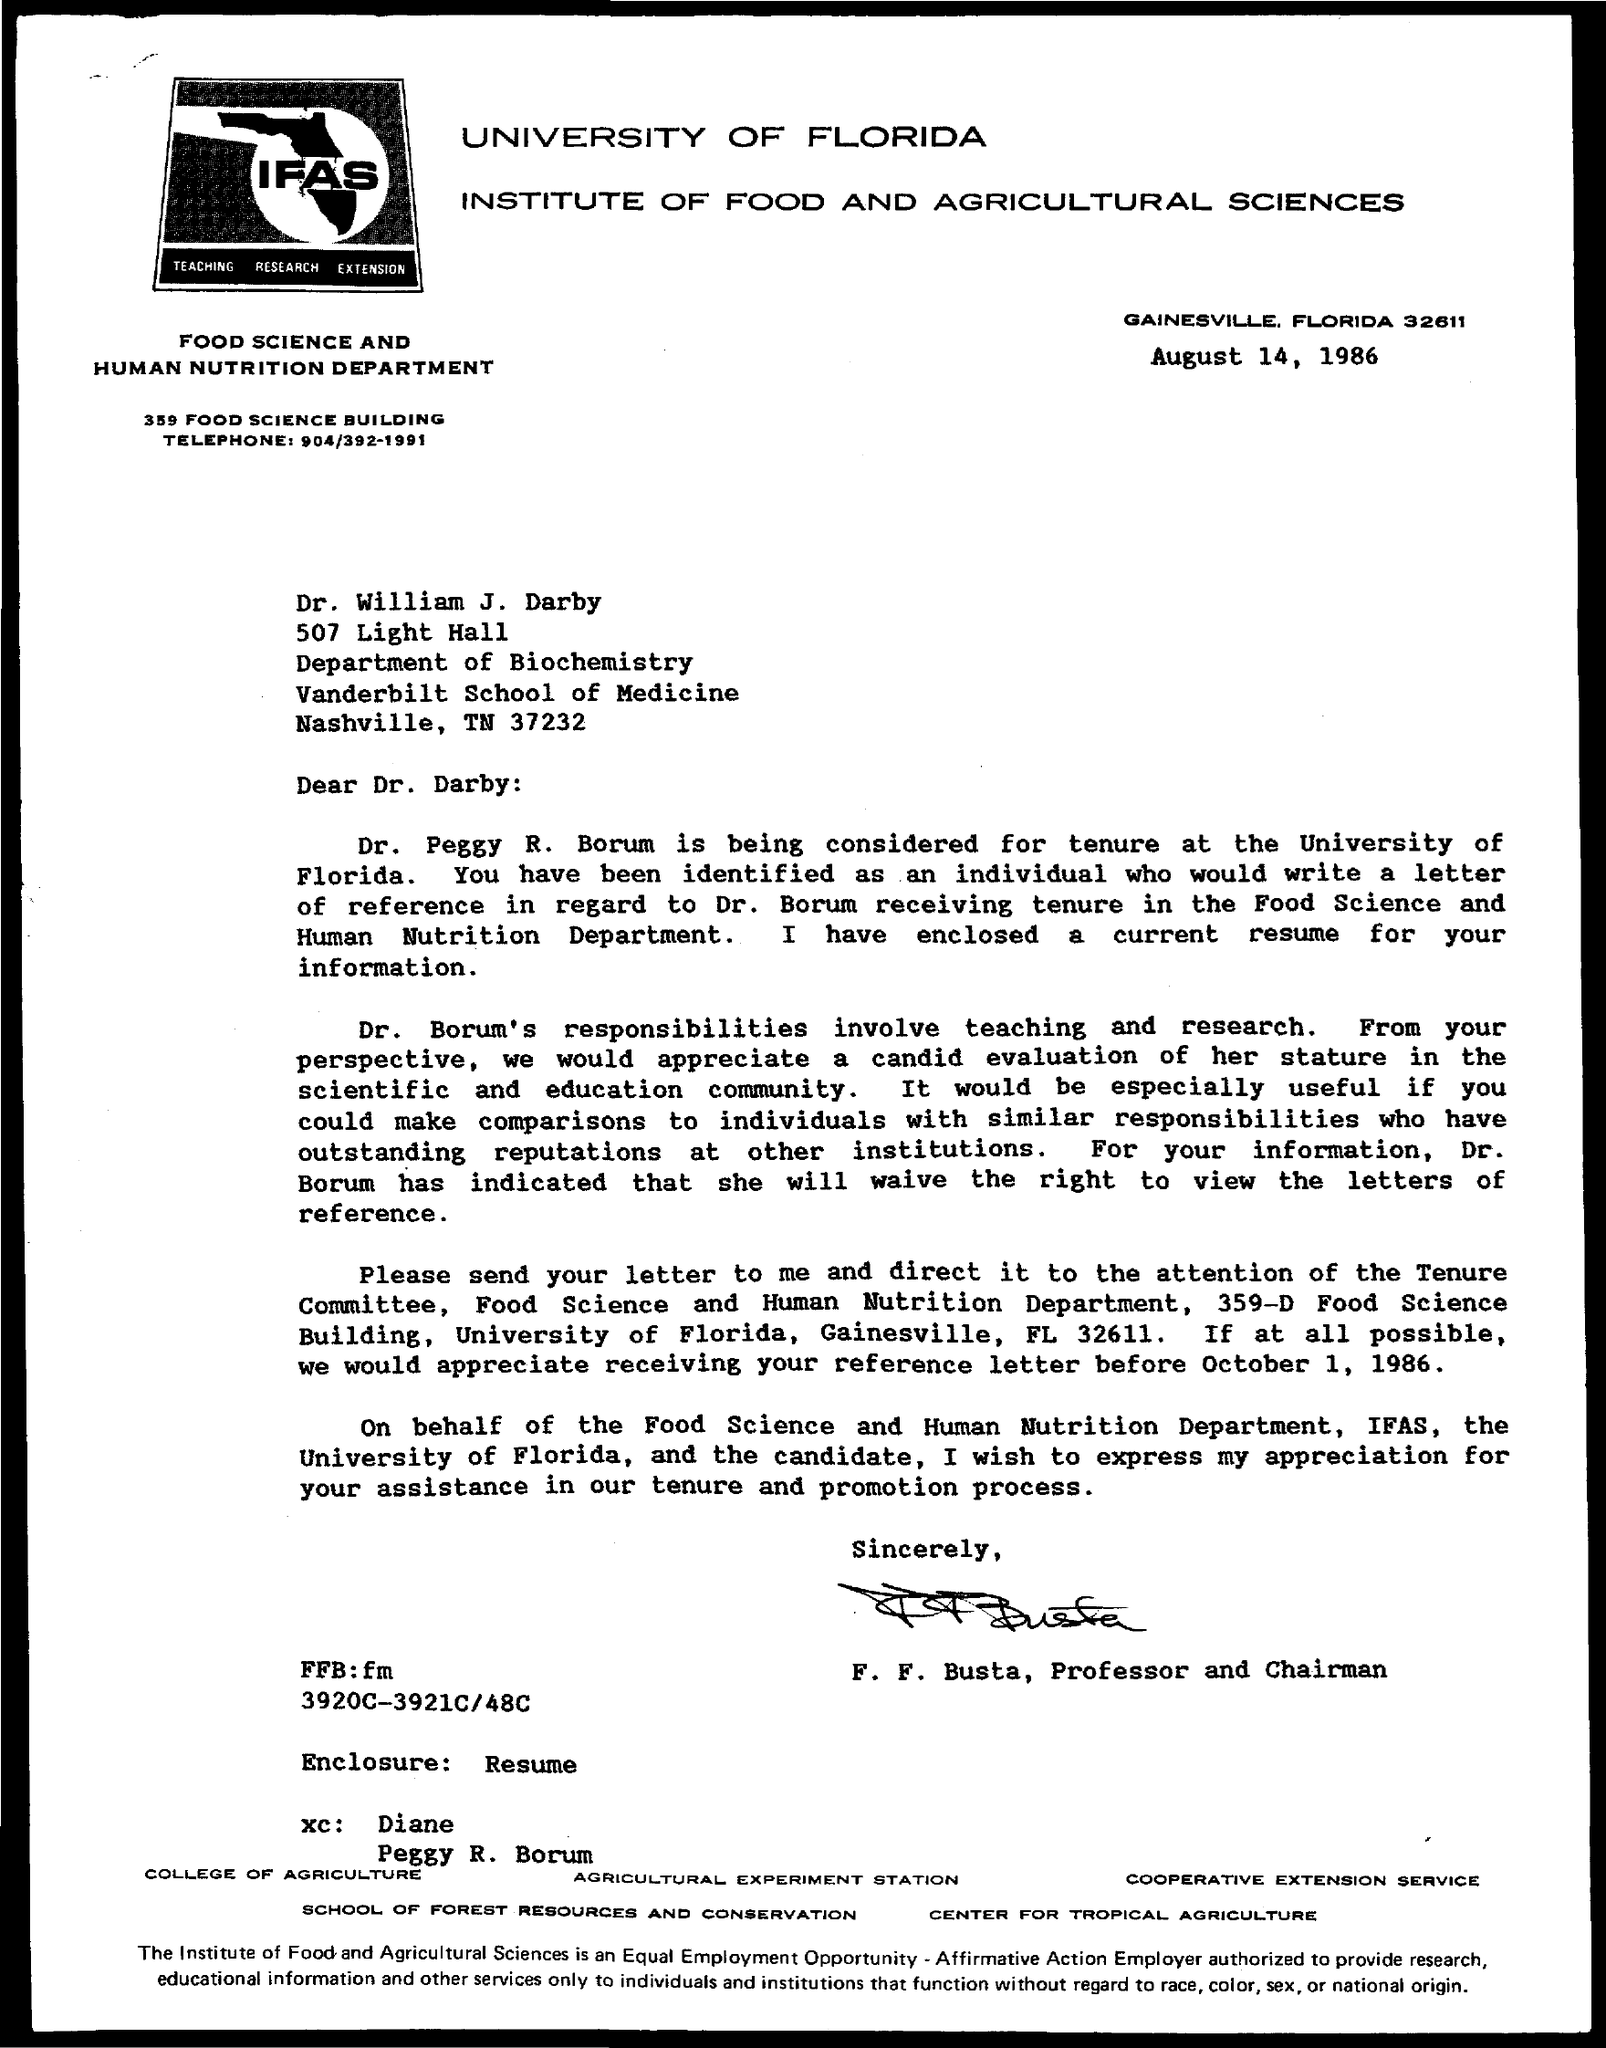Draw attention to some important aspects in this diagram. The document's date is August 14, 1986, as indicated on the document. This letter is addressed to Dr. William J. Darby. 